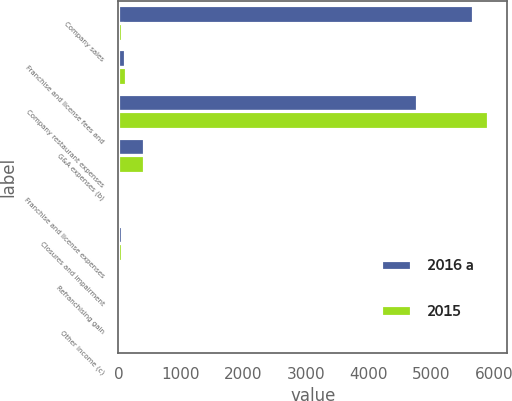<chart> <loc_0><loc_0><loc_500><loc_500><stacked_bar_chart><ecel><fcel>Company sales<fcel>Franchise and license fees and<fcel>Company restaurant expenses<fcel>G&A expenses (b)<fcel>Franchise and license expenses<fcel>Closures and impairment<fcel>Refranchising gain<fcel>Other income (c)<nl><fcel>2016 a<fcel>5667<fcel>109<fcel>4766<fcel>406<fcel>45<fcel>57<fcel>12<fcel>49<nl><fcel>2015<fcel>64<fcel>120<fcel>5913<fcel>405<fcel>48<fcel>64<fcel>13<fcel>27<nl></chart> 